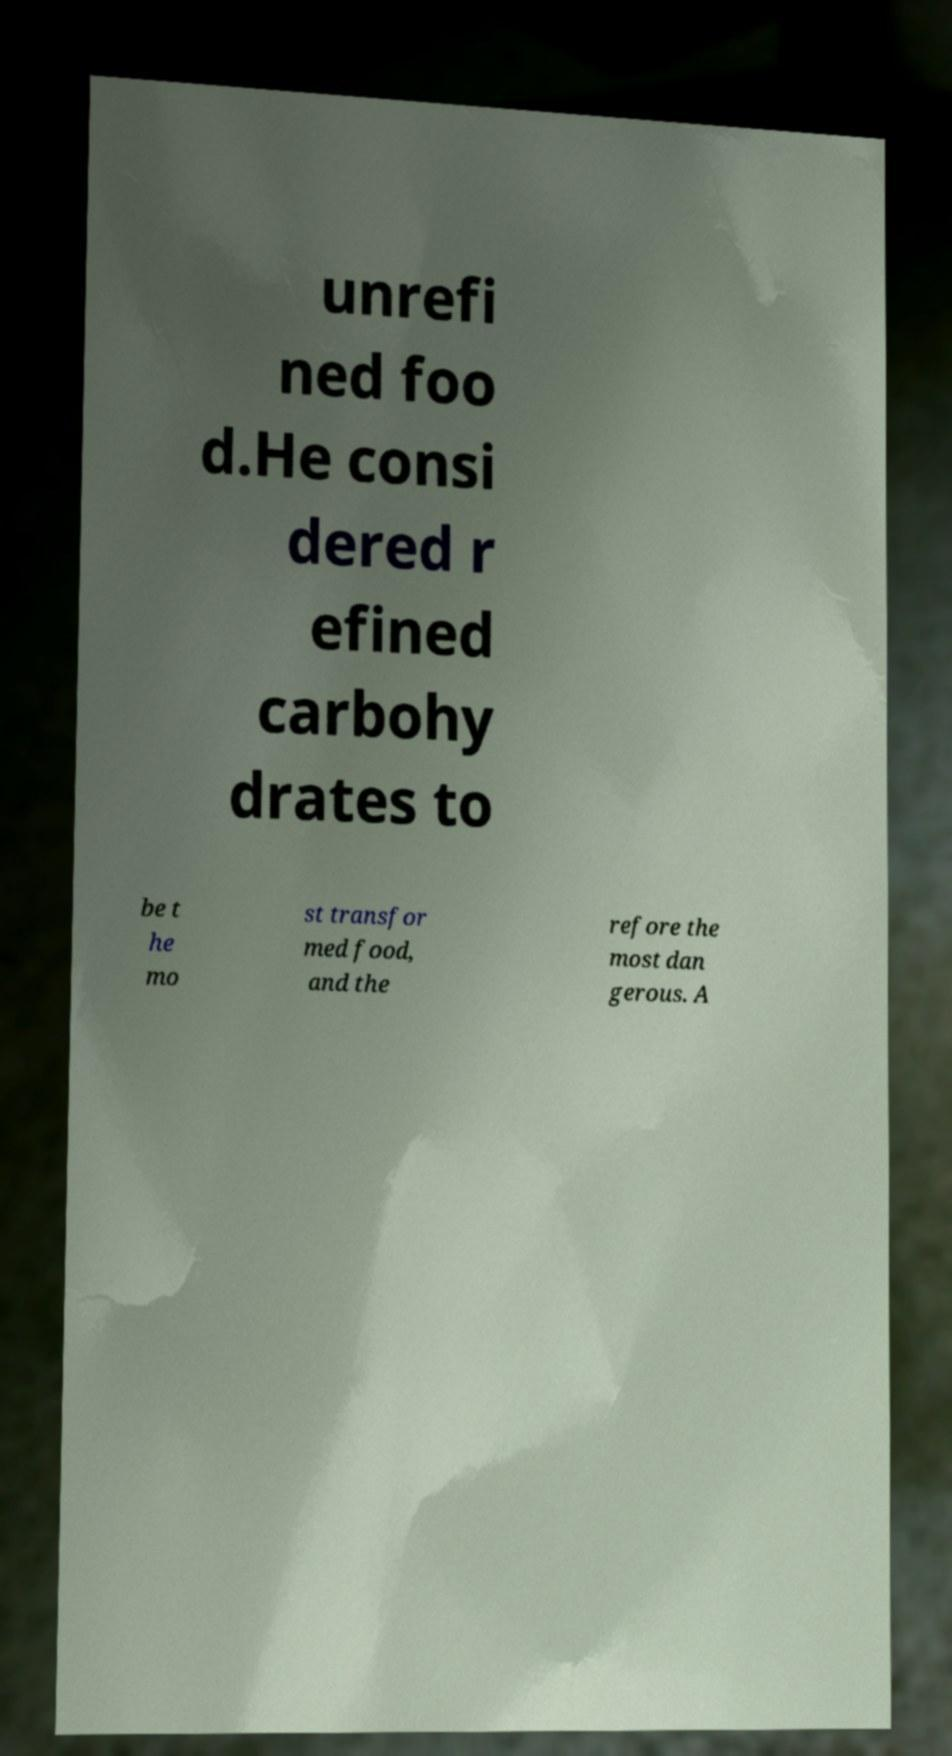Could you extract and type out the text from this image? unrefi ned foo d.He consi dered r efined carbohy drates to be t he mo st transfor med food, and the refore the most dan gerous. A 